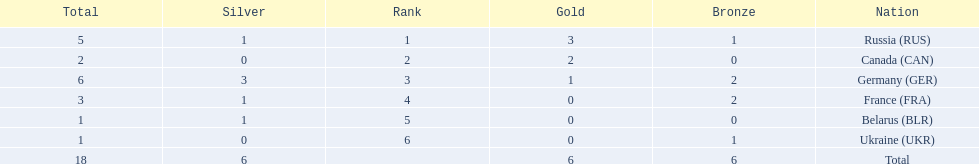Which countries received gold medals? Russia (RUS), Canada (CAN), Germany (GER). Of these countries, which did not receive a silver medal? Canada (CAN). 